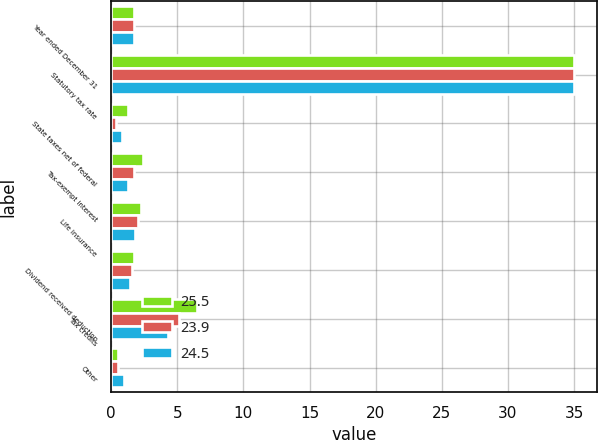Convert chart to OTSL. <chart><loc_0><loc_0><loc_500><loc_500><stacked_bar_chart><ecel><fcel>Year ended December 31<fcel>Statutory tax rate<fcel>State taxes net of federal<fcel>Tax-exempt interest<fcel>Life insurance<fcel>Dividend received deduction<fcel>Tax credits<fcel>Other<nl><fcel>25.5<fcel>1.7<fcel>35<fcel>1.3<fcel>2.4<fcel>2.3<fcel>1.7<fcel>6.5<fcel>0.5<nl><fcel>23.9<fcel>1.7<fcel>35<fcel>0.4<fcel>1.7<fcel>2<fcel>1.6<fcel>5.1<fcel>0.5<nl><fcel>24.5<fcel>1.7<fcel>35<fcel>0.8<fcel>1.3<fcel>1.8<fcel>1.4<fcel>4.3<fcel>1<nl></chart> 